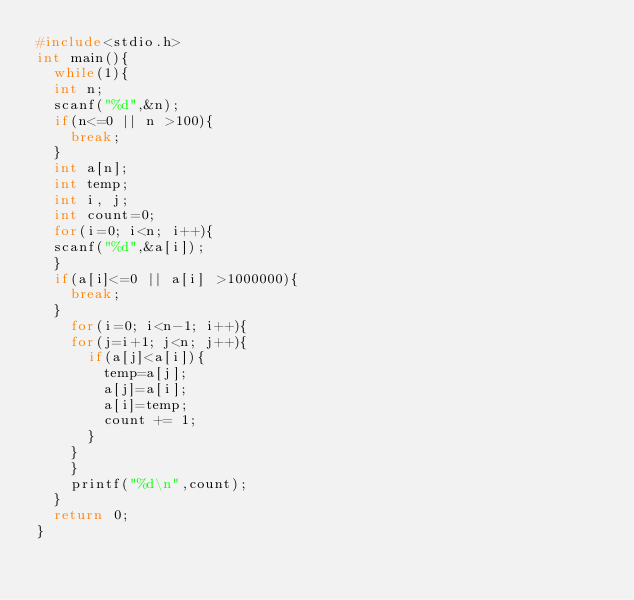<code> <loc_0><loc_0><loc_500><loc_500><_C_>#include<stdio.h>
int main(){
  while(1){
  int n;
  scanf("%d",&n);
  if(n<=0 || n >100){
    break;
  }
  int a[n];
  int temp;
  int i, j;
  int count=0;
  for(i=0; i<n; i++){
  scanf("%d",&a[i]);
  }
  if(a[i]<=0 || a[i] >1000000){
    break;
  }
    for(i=0; i<n-1; i++){
    for(j=i+1; j<n; j++){
      if(a[j]<a[i]){
        temp=a[j];
        a[j]=a[i];
        a[i]=temp;
        count += 1;
      }    
    }
    }
    printf("%d\n",count);
  }
  return 0;
}</code> 